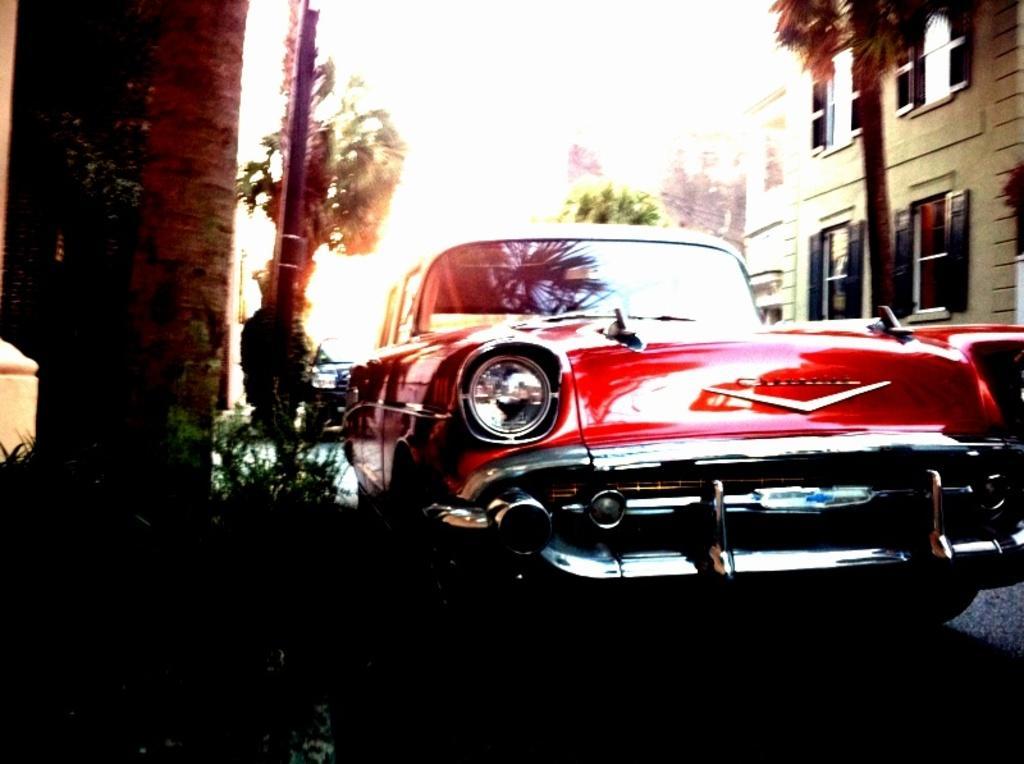How would you summarize this image in a sentence or two? In the foreground I can see a car, vehicles on the road. In the background I can see buildings, trees, windows and the sky. This image is taken on the road. 